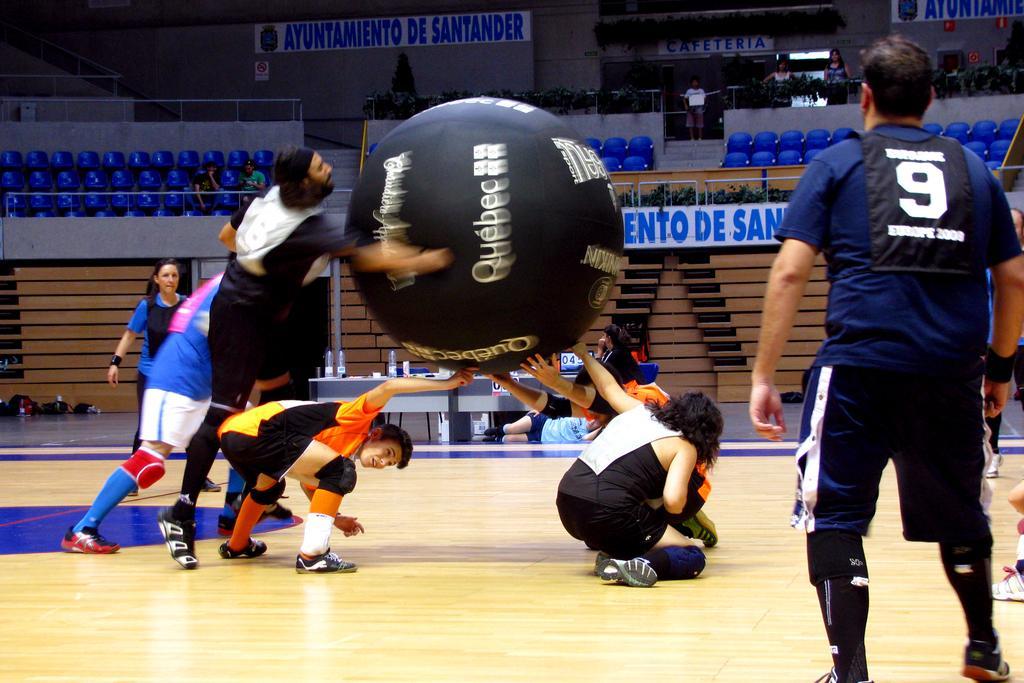Could you give a brief overview of what you see in this image? In this image, there are some persons wearing clothes and holding a ball with their hands. There is an another person on the right side of the image standing and wearing clothes. There are some chairs in the top left and in the top right of the image. 